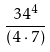<formula> <loc_0><loc_0><loc_500><loc_500>\frac { 3 4 ^ { 4 } } { ( 4 \cdot 7 ) }</formula> 